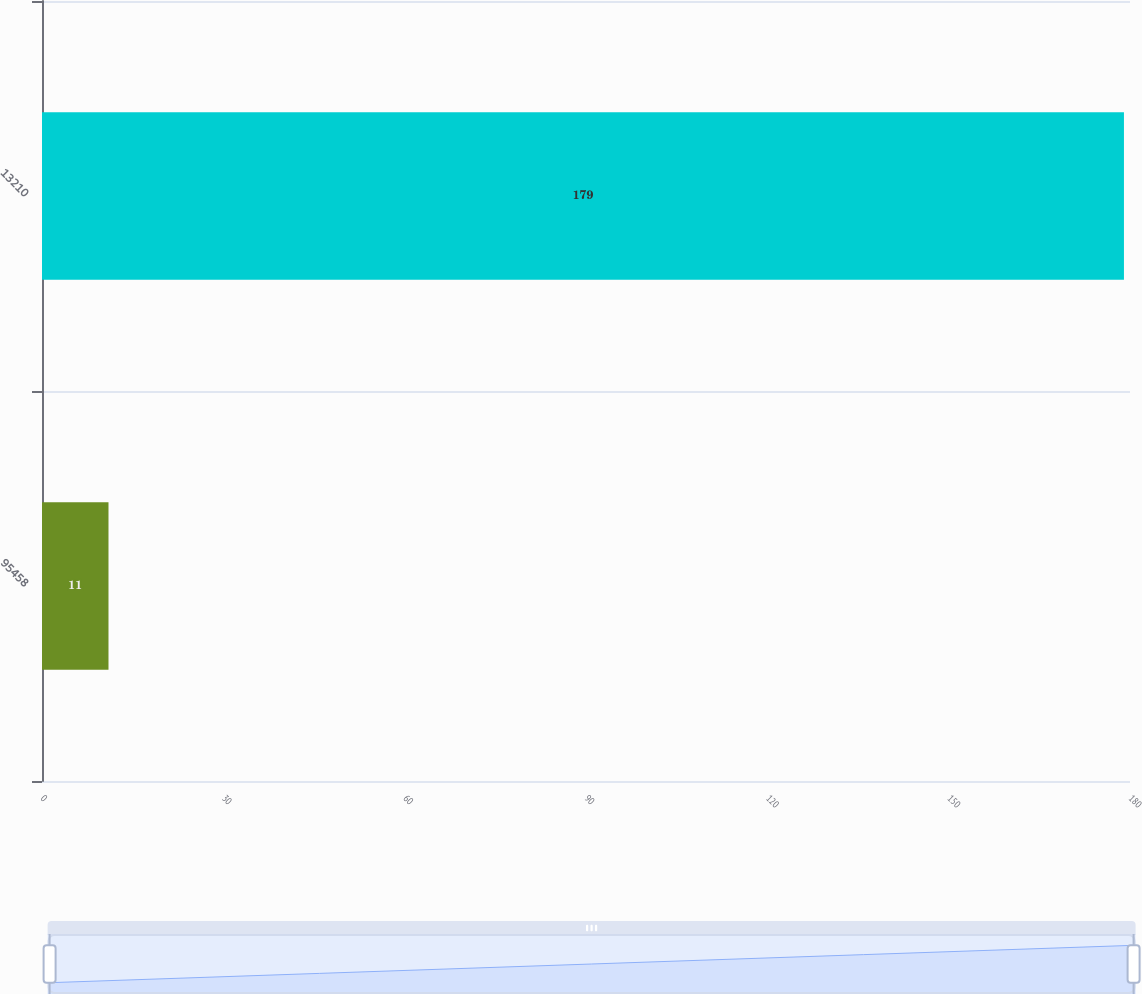<chart> <loc_0><loc_0><loc_500><loc_500><bar_chart><fcel>95458<fcel>13210<nl><fcel>11<fcel>179<nl></chart> 